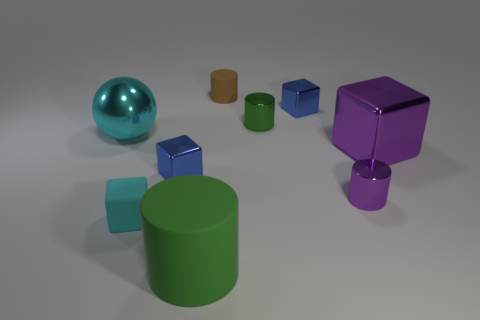The large metallic thing that is behind the large purple metallic thing is what color? The large object positioned behind the purple one is of a teal hue, reflecting light with a subtle shine that suggests it is metallic as well. 